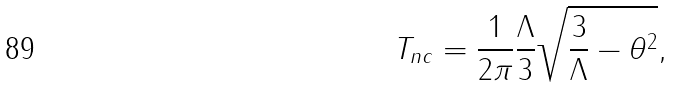Convert formula to latex. <formula><loc_0><loc_0><loc_500><loc_500>T _ { n c } = \frac { 1 } { 2 \pi } \frac { \Lambda } { 3 } \sqrt { \frac { 3 } { \Lambda } - \theta ^ { 2 } } ,</formula> 